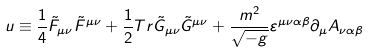<formula> <loc_0><loc_0><loc_500><loc_500>u \equiv \frac { 1 } { 4 } \tilde { F } _ { \mu \nu } \tilde { F } ^ { \mu \nu } + \frac { 1 } { 2 } T r \tilde { G } _ { \mu \nu } \tilde { G } ^ { \mu \nu } + \frac { m ^ { 2 } } { \sqrt { - g } } \varepsilon ^ { \mu \nu \alpha \beta } \partial _ { \mu } A _ { \nu \alpha \beta }</formula> 